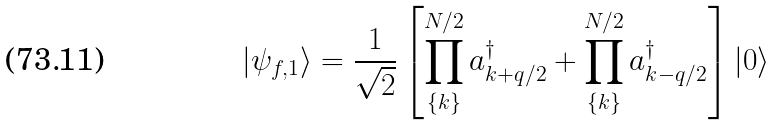<formula> <loc_0><loc_0><loc_500><loc_500>| \psi _ { f , 1 } \rangle = \frac { 1 } { \sqrt { 2 } } \left [ \prod _ { \{ k \} } ^ { N / 2 } a _ { k + q / 2 } ^ { \dagger } + \prod _ { \{ k \} } ^ { N / 2 } a _ { k - q / 2 } ^ { \dagger } \right ] | 0 \rangle</formula> 